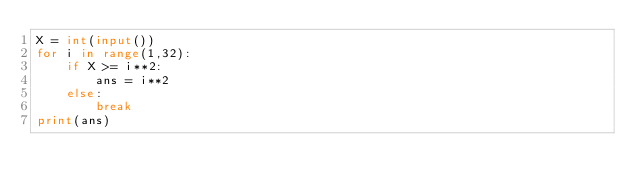<code> <loc_0><loc_0><loc_500><loc_500><_Python_>X = int(input())
for i in range(1,32):
    if X >= i**2:
        ans = i**2
    else:
        break
print(ans)</code> 